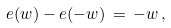<formula> <loc_0><loc_0><loc_500><loc_500>e ( w ) - e ( - w ) \, = \, - w \, ,</formula> 